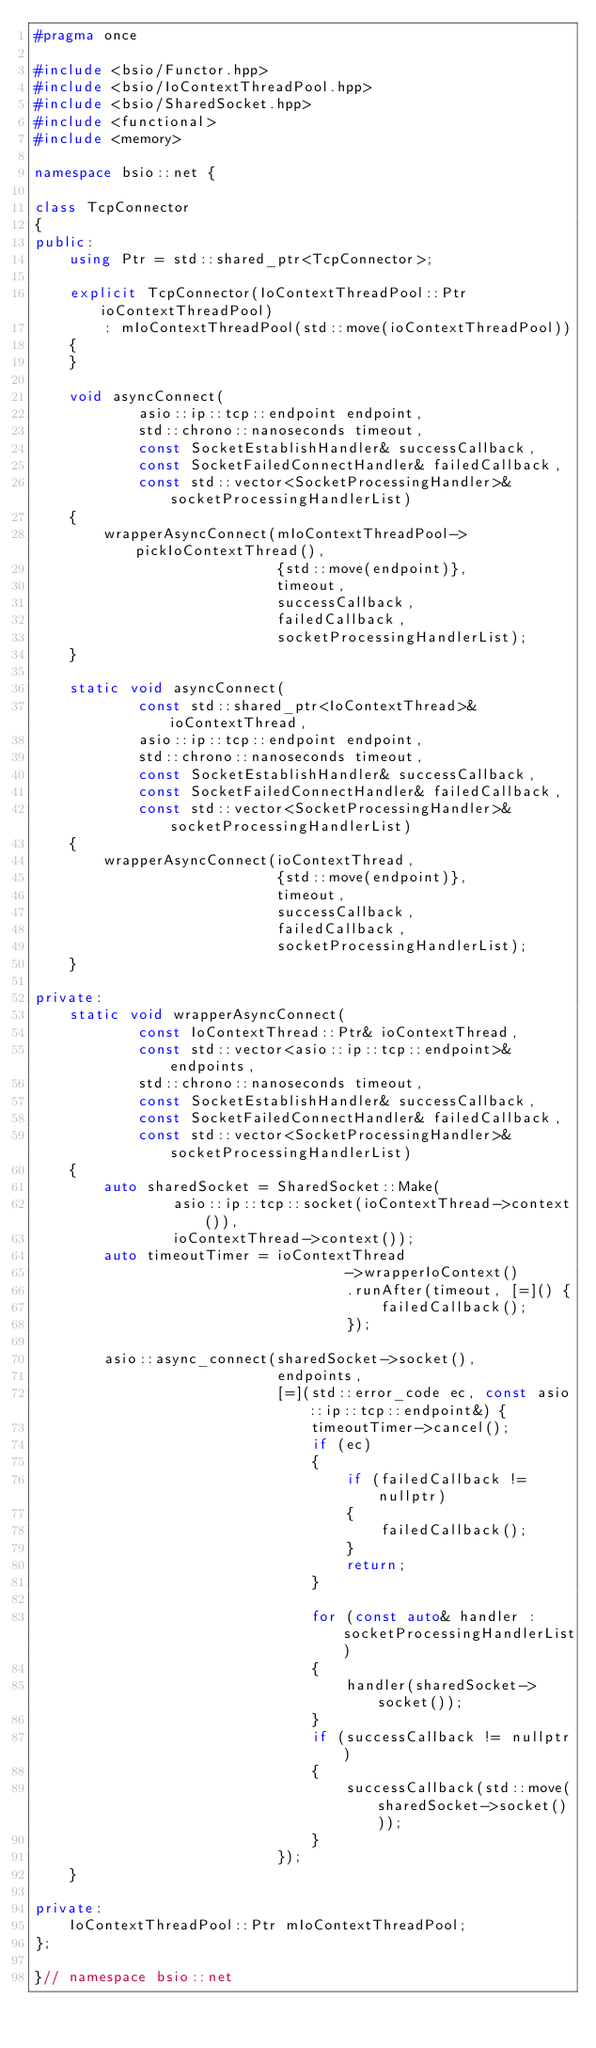Convert code to text. <code><loc_0><loc_0><loc_500><loc_500><_C++_>#pragma once

#include <bsio/Functor.hpp>
#include <bsio/IoContextThreadPool.hpp>
#include <bsio/SharedSocket.hpp>
#include <functional>
#include <memory>

namespace bsio::net {

class TcpConnector
{
public:
    using Ptr = std::shared_ptr<TcpConnector>;

    explicit TcpConnector(IoContextThreadPool::Ptr ioContextThreadPool)
        : mIoContextThreadPool(std::move(ioContextThreadPool))
    {
    }

    void asyncConnect(
            asio::ip::tcp::endpoint endpoint,
            std::chrono::nanoseconds timeout,
            const SocketEstablishHandler& successCallback,
            const SocketFailedConnectHandler& failedCallback,
            const std::vector<SocketProcessingHandler>& socketProcessingHandlerList)
    {
        wrapperAsyncConnect(mIoContextThreadPool->pickIoContextThread(),
                            {std::move(endpoint)},
                            timeout,
                            successCallback,
                            failedCallback,
                            socketProcessingHandlerList);
    }

    static void asyncConnect(
            const std::shared_ptr<IoContextThread>& ioContextThread,
            asio::ip::tcp::endpoint endpoint,
            std::chrono::nanoseconds timeout,
            const SocketEstablishHandler& successCallback,
            const SocketFailedConnectHandler& failedCallback,
            const std::vector<SocketProcessingHandler>& socketProcessingHandlerList)
    {
        wrapperAsyncConnect(ioContextThread,
                            {std::move(endpoint)},
                            timeout,
                            successCallback,
                            failedCallback,
                            socketProcessingHandlerList);
    }

private:
    static void wrapperAsyncConnect(
            const IoContextThread::Ptr& ioContextThread,
            const std::vector<asio::ip::tcp::endpoint>& endpoints,
            std::chrono::nanoseconds timeout,
            const SocketEstablishHandler& successCallback,
            const SocketFailedConnectHandler& failedCallback,
            const std::vector<SocketProcessingHandler>& socketProcessingHandlerList)
    {
        auto sharedSocket = SharedSocket::Make(
                asio::ip::tcp::socket(ioContextThread->context()),
                ioContextThread->context());
        auto timeoutTimer = ioContextThread
                                    ->wrapperIoContext()
                                    .runAfter(timeout, [=]() {
                                        failedCallback();
                                    });

        asio::async_connect(sharedSocket->socket(),
                            endpoints,
                            [=](std::error_code ec, const asio::ip::tcp::endpoint&) {
                                timeoutTimer->cancel();
                                if (ec)
                                {
                                    if (failedCallback != nullptr)
                                    {
                                        failedCallback();
                                    }
                                    return;
                                }

                                for (const auto& handler : socketProcessingHandlerList)
                                {
                                    handler(sharedSocket->socket());
                                }
                                if (successCallback != nullptr)
                                {
                                    successCallback(std::move(sharedSocket->socket()));
                                }
                            });
    }

private:
    IoContextThreadPool::Ptr mIoContextThreadPool;
};

}// namespace bsio::net
</code> 